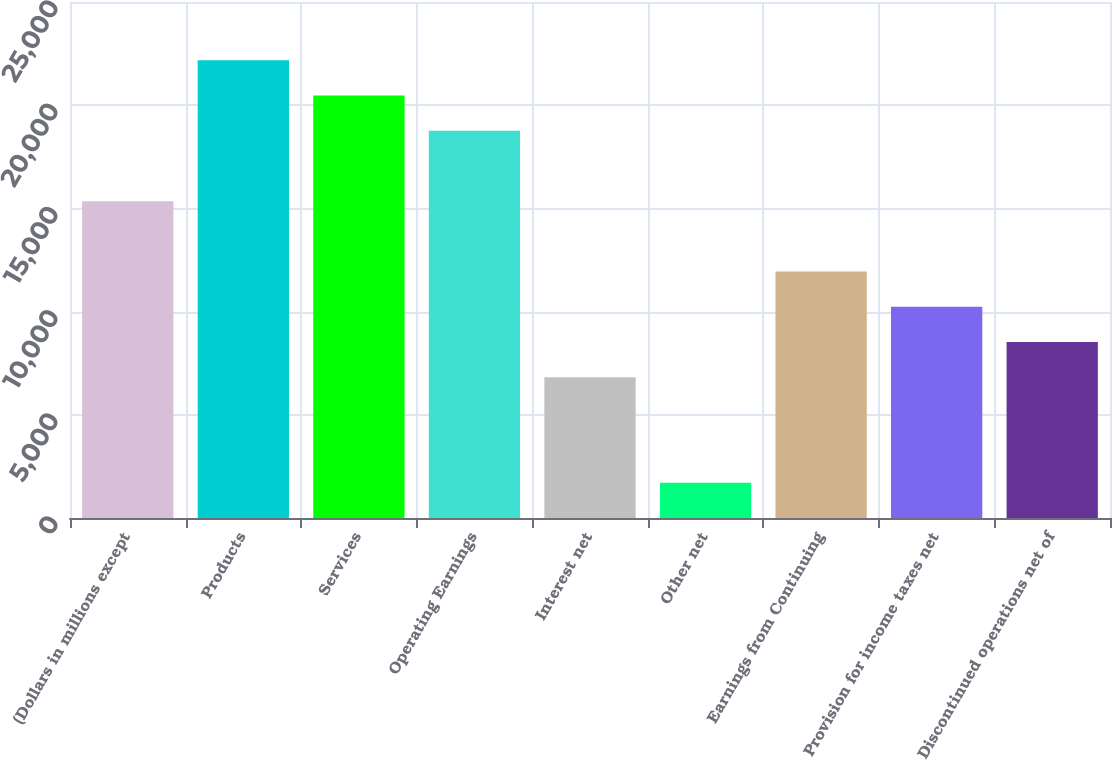Convert chart to OTSL. <chart><loc_0><loc_0><loc_500><loc_500><bar_chart><fcel>(Dollars in millions except<fcel>Products<fcel>Services<fcel>Operating Earnings<fcel>Interest net<fcel>Other net<fcel>Earnings from Continuing<fcel>Provision for income taxes net<fcel>Discontinued operations net of<nl><fcel>15351.3<fcel>22173.9<fcel>20468.3<fcel>18762.6<fcel>6823<fcel>1706.02<fcel>11940<fcel>10234.3<fcel>8528.66<nl></chart> 